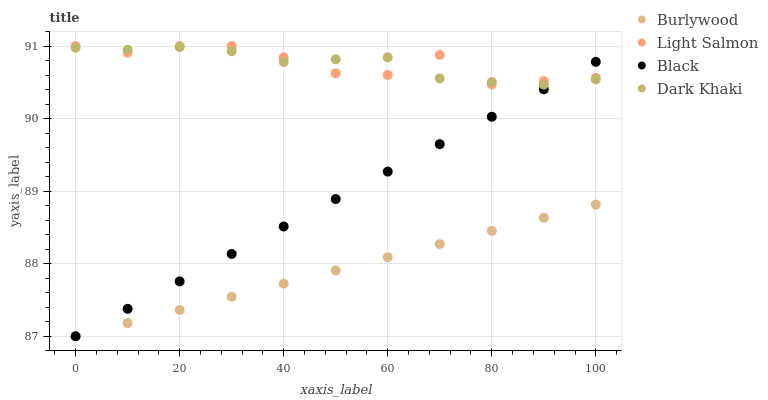Does Burlywood have the minimum area under the curve?
Answer yes or no. Yes. Does Light Salmon have the maximum area under the curve?
Answer yes or no. Yes. Does Dark Khaki have the minimum area under the curve?
Answer yes or no. No. Does Dark Khaki have the maximum area under the curve?
Answer yes or no. No. Is Black the smoothest?
Answer yes or no. Yes. Is Light Salmon the roughest?
Answer yes or no. Yes. Is Dark Khaki the smoothest?
Answer yes or no. No. Is Dark Khaki the roughest?
Answer yes or no. No. Does Burlywood have the lowest value?
Answer yes or no. Yes. Does Dark Khaki have the lowest value?
Answer yes or no. No. Does Light Salmon have the highest value?
Answer yes or no. Yes. Does Dark Khaki have the highest value?
Answer yes or no. No. Is Burlywood less than Light Salmon?
Answer yes or no. Yes. Is Light Salmon greater than Burlywood?
Answer yes or no. Yes. Does Dark Khaki intersect Black?
Answer yes or no. Yes. Is Dark Khaki less than Black?
Answer yes or no. No. Is Dark Khaki greater than Black?
Answer yes or no. No. Does Burlywood intersect Light Salmon?
Answer yes or no. No. 